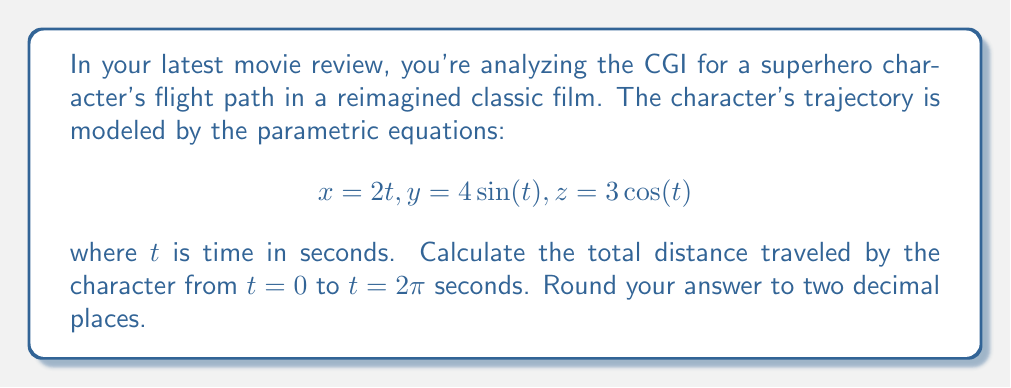Could you help me with this problem? To solve this problem, we'll follow these steps:

1) The trajectory is given by parametric equations in 3D space. To find the total distance, we need to calculate the arc length of the curve.

2) The formula for arc length in 3D parametric equations is:

   $$L = \int_{a}^{b} \sqrt{\left(\frac{dx}{dt}\right)^2 + \left(\frac{dy}{dt}\right)^2 + \left(\frac{dz}{dt}\right)^2} dt$$

3) First, let's find the derivatives:
   
   $$\frac{dx}{dt} = 2$$
   $$\frac{dy}{dt} = 4\cos(t)$$
   $$\frac{dz}{dt} = -3\sin(t)$$

4) Now, let's substitute these into our arc length formula:

   $$L = \int_{0}^{2\pi} \sqrt{2^2 + (4\cos(t))^2 + (-3\sin(t))^2} dt$$

5) Simplify under the square root:

   $$L = \int_{0}^{2\pi} \sqrt{4 + 16\cos^2(t) + 9\sin^2(t)} dt$$

6) Recall the trigonometric identity $\cos^2(t) + \sin^2(t) = 1$. We can use this to simplify further:

   $$L = \int_{0}^{2\pi} \sqrt{4 + 16\cos^2(t) + 9(1-\cos^2(t))} dt$$
   $$L = \int_{0}^{2\pi} \sqrt{13 + 7\cos^2(t)} dt$$

7) This integral doesn't have an elementary antiderivative. We need to use numerical integration methods or a calculator to evaluate it.

8) Using a numerical integration method, we get approximately 28.81 units.
Answer: The total distance traveled by the CGI character is approximately 28.81 units. 